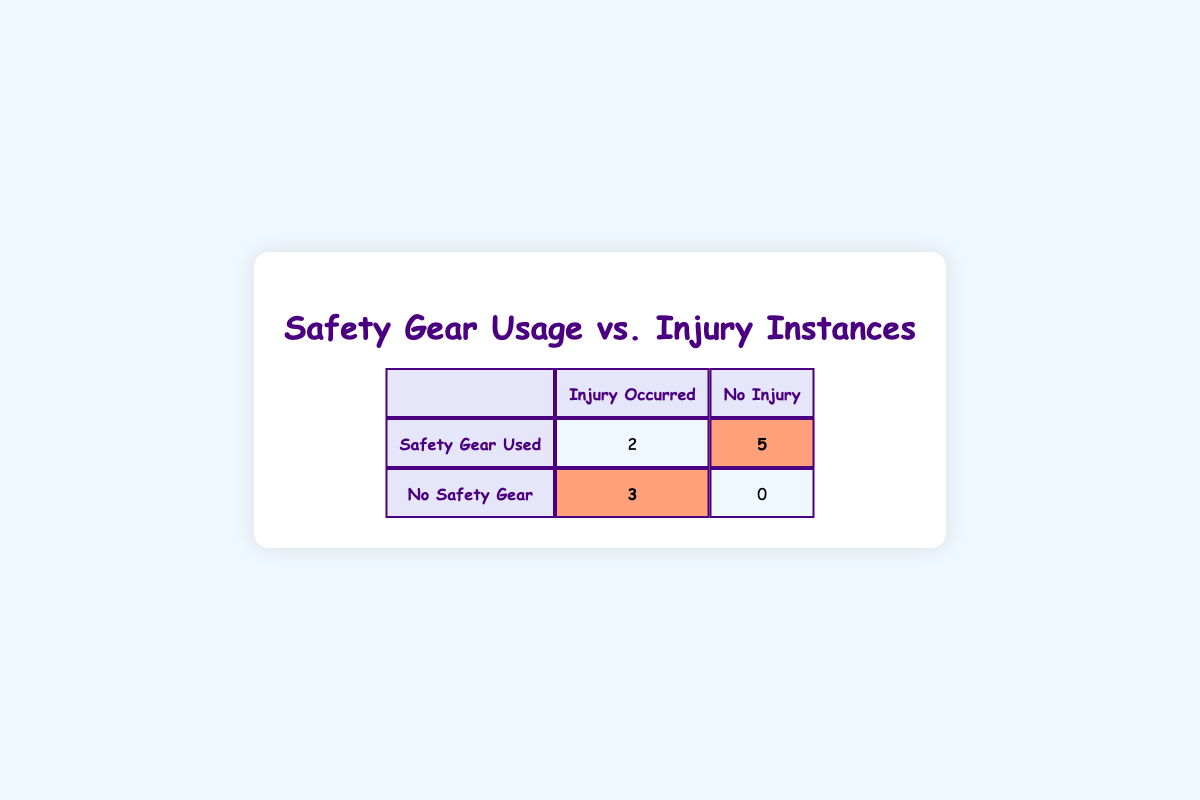What is the total number of children who used safety gear? From the table, the group 'Safety Gear Used' includes 7 instances (2 with injury and 5 without injury) which indicates that 7 children used safety gear.
Answer: 7 How many children sustained an injury while not using any safety gear? Referencing the 'No Safety Gear' row, we see that 3 children (highlighted in the table) had injuries, confirming that all 3 sustained injuries without safety gear.
Answer: 3 What is the total number of children who did not sustain any injuries? The total number of children who did not sustain injuries can be derived from the 'No Injury' column, which distinctly shows 5 children.
Answer: 5 Is it true that more children who used safety gear sustained injuries than those who did not? Evaluating the table, we see 2 children who used safety gear experienced injuries, while 3 children without safety gear experienced injuries, showing that the latter group had more injuries. Hence, it is false.
Answer: No What is the difference in the number of children with injuries between those using safety gear and those without? For children using safety gear, there are 2 with injuries; for those without, there are 3. The difference is 3 (without) - 2 (with) = 1.
Answer: 1 How many children in total were analyzed in this study? Adding both groups together: 2 (injury with gear) + 5 (no injury with gear) + 3 (injury without gear) + 0 (no injury without gear) = 10 children were analyzed.
Answer: 10 Are there any cases of injuries among children using both helmets and knee pads? Looking closely, in the table, there is one instance (child_id 10) where both items were used, and it shows that this child did sustain an injury. Thus, the answer is yes.
Answer: Yes If a child uses safety gear, what is the probability of them not sustaining an injury? From the data, 5 children using safety gear did not sustain injuries out of a total of 7 who used safety gear. The probability is calculated as 5/7, resulting in approximately 0.71 or 71%.
Answer: 71% 